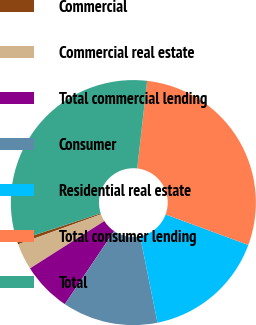<chart> <loc_0><loc_0><loc_500><loc_500><pie_chart><fcel>Commercial<fcel>Commercial real estate<fcel>Total commercial lending<fcel>Consumer<fcel>Residential real estate<fcel>Total consumer lending<fcel>Total<nl><fcel>0.47%<fcel>3.5%<fcel>6.53%<fcel>12.6%<fcel>16.22%<fcel>28.82%<fcel>31.85%<nl></chart> 